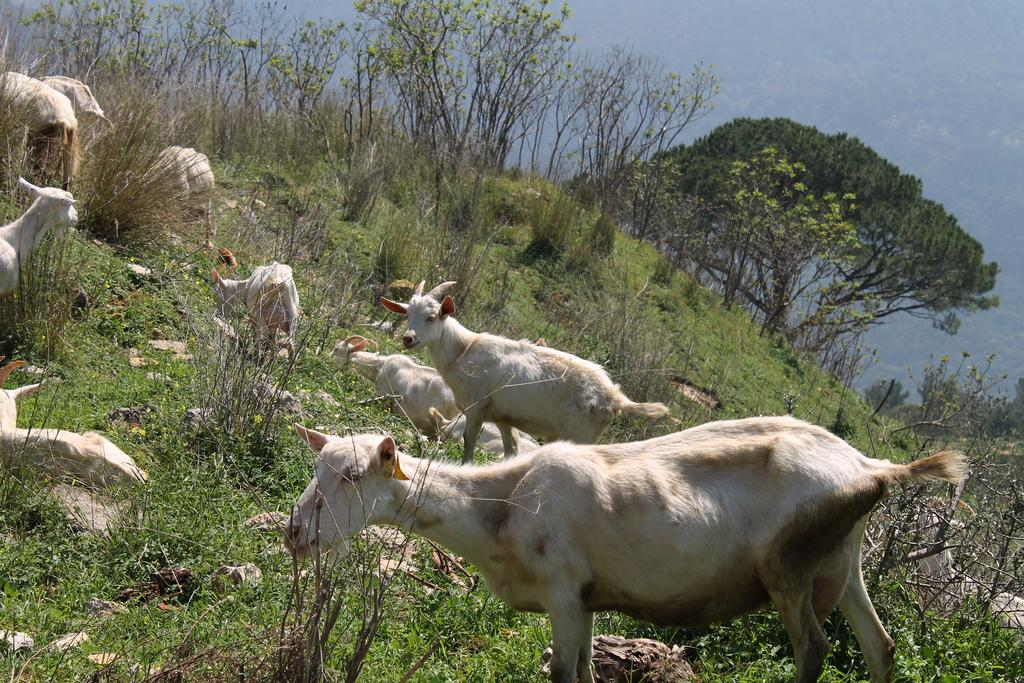What animals are present in the image? There are goats in the image. What can be seen in the background of the image? There are trees in the background of the image. What is covering the ground at the bottom of the image? The ground is covered with plants at the bottom of the image. What type of yam is being used for learning in the image? There is no yam or learning activity present in the image; it features goats and trees. 